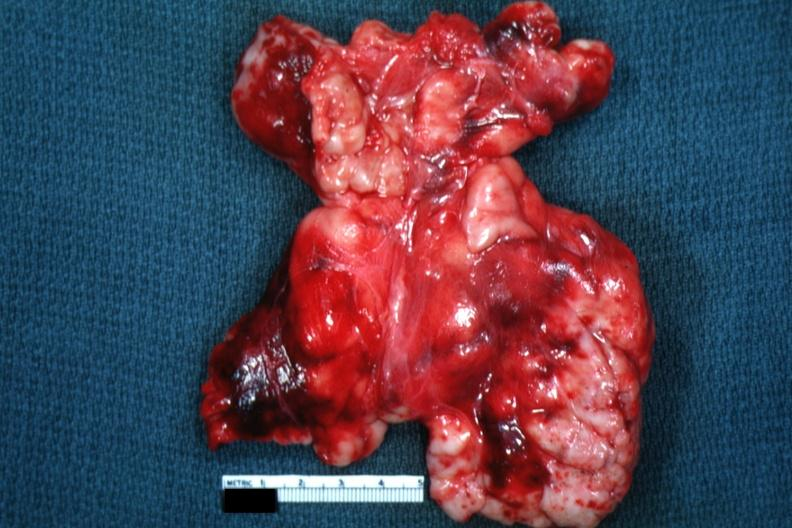does atrophy secondary to pituitectomy appear as large mass of matted nodes like malignant lymphoma?
Answer the question using a single word or phrase. No 